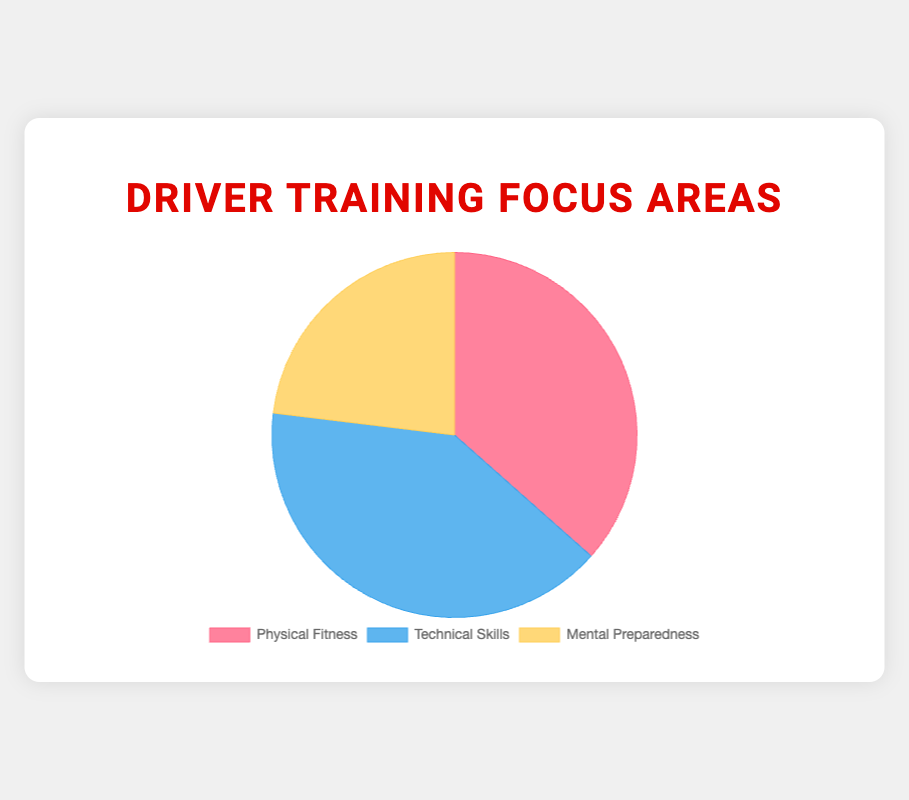What percentage of training hours is dedicated to Physical Fitness? The percentage of training hours dedicated to Physical Fitness is calculated by taking the training hours for Physical Fitness (19 hours) and dividing it by the total training hours across all categories (19 + 21 + 12 = 52), then multiplying by 100. So, (19/52) * 100 = 36.54%.
Answer: 36.54% What is the difference in training hours between Technical Skills and Mental Preparedness? The training hours for Technical Skills are 21 and for Mental Preparedness are 12. The difference is calculated by subtracting the hours of Mental Preparedness from Technical Skills: 21 - 12.
Answer: 9 hours Which training focus area has the highest number of hours? By looking at the chart, we see that Technical Skills has the largest share of training hours. The data confirms this with Technical Skills accumulating 21 hours.
Answer: Technical Skills Which training focus area has the lowest number of hours? By observing the chart, Mental Preparedness occupies the smallest portion of the pie chart. The data shows it has 12 hours dedicated.
Answer: Mental Preparedness Comparing Physical Fitness and Technical Skills, which area has more training hours and by how much? Physical Fitness has 19 hours, and Technical Skills has 21 hours. Subtract the hours of Physical Fitness from Technical Skills to find the difference: 21 - 19. Therefore, Technical Skills has 2 more hours.
Answer: Technical Skills by 2 hours What is the total number of training hours across all focus areas? To find the total number of training hours, sum the hours from all three categories: Physical Fitness (19 hours) + Technical Skills (21 hours) + Mental Preparedness (12 hours) = 52 hours.
Answer: 52 hours If a new driver adds 8 hours of training to Mental Preparedness, would it surpass the hours dedicated to Physical Fitness? Initially, Mental Preparedness has 12 hours. Adding 8 hours results in 20 hours. Since Physical Fitness has 19 hours, Mental Preparedness would indeed surpass Physical Fitness: 20 > 19.
Answer: Yes Which color represents the Mental Preparedness training focus area in the chart? According to the color codes provided, Mental Preparedness is represented by the yellowish color in the pie chart.
Answer: Yellow 